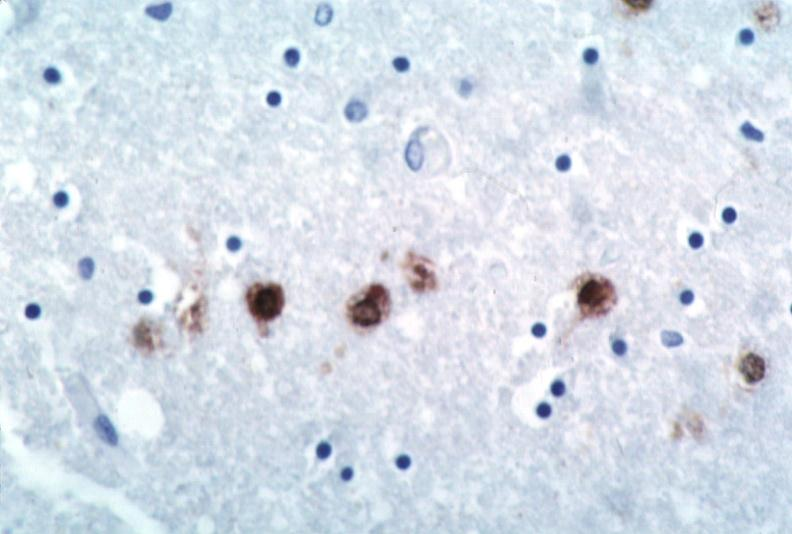s nervous present?
Answer the question using a single word or phrase. Yes 